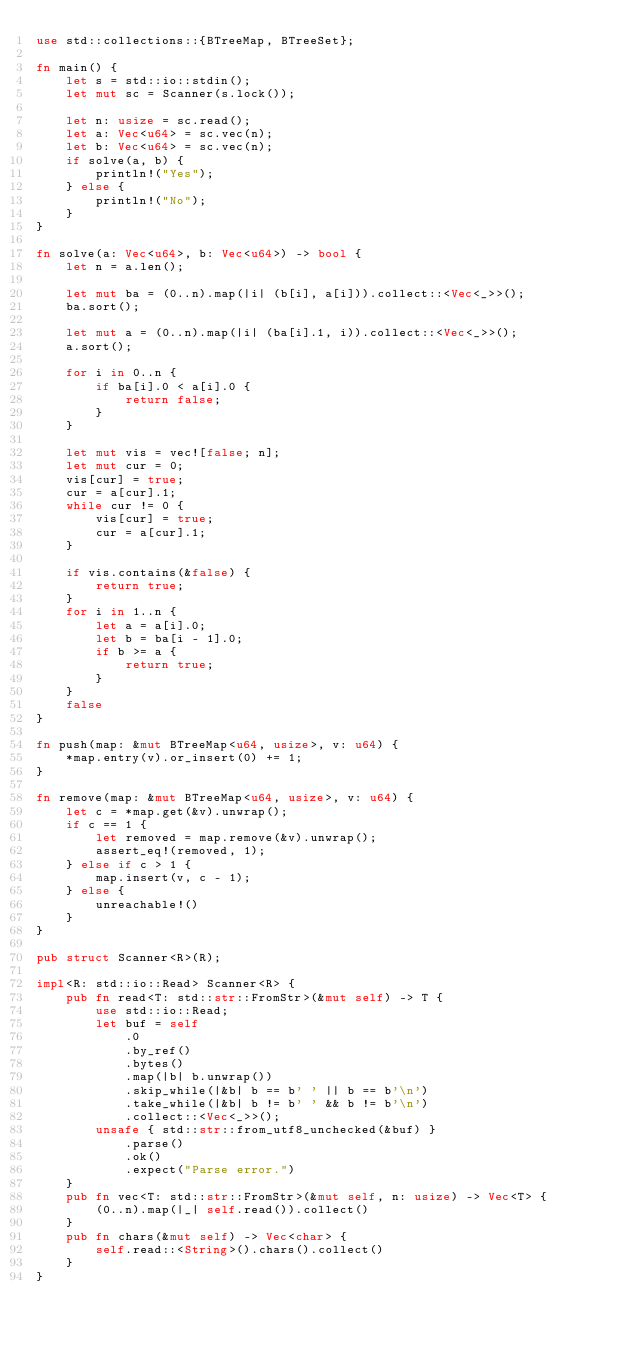<code> <loc_0><loc_0><loc_500><loc_500><_Rust_>use std::collections::{BTreeMap, BTreeSet};

fn main() {
    let s = std::io::stdin();
    let mut sc = Scanner(s.lock());

    let n: usize = sc.read();
    let a: Vec<u64> = sc.vec(n);
    let b: Vec<u64> = sc.vec(n);
    if solve(a, b) {
        println!("Yes");
    } else {
        println!("No");
    }
}

fn solve(a: Vec<u64>, b: Vec<u64>) -> bool {
    let n = a.len();

    let mut ba = (0..n).map(|i| (b[i], a[i])).collect::<Vec<_>>();
    ba.sort();

    let mut a = (0..n).map(|i| (ba[i].1, i)).collect::<Vec<_>>();
    a.sort();

    for i in 0..n {
        if ba[i].0 < a[i].0 {
            return false;
        }
    }

    let mut vis = vec![false; n];
    let mut cur = 0;
    vis[cur] = true;
    cur = a[cur].1;
    while cur != 0 {
        vis[cur] = true;
        cur = a[cur].1;
    }

    if vis.contains(&false) {
        return true;
    }
    for i in 1..n {
        let a = a[i].0;
        let b = ba[i - 1].0;
        if b >= a {
            return true;
        }
    }
    false
}

fn push(map: &mut BTreeMap<u64, usize>, v: u64) {
    *map.entry(v).or_insert(0) += 1;
}

fn remove(map: &mut BTreeMap<u64, usize>, v: u64) {
    let c = *map.get(&v).unwrap();
    if c == 1 {
        let removed = map.remove(&v).unwrap();
        assert_eq!(removed, 1);
    } else if c > 1 {
        map.insert(v, c - 1);
    } else {
        unreachable!()
    }
}

pub struct Scanner<R>(R);

impl<R: std::io::Read> Scanner<R> {
    pub fn read<T: std::str::FromStr>(&mut self) -> T {
        use std::io::Read;
        let buf = self
            .0
            .by_ref()
            .bytes()
            .map(|b| b.unwrap())
            .skip_while(|&b| b == b' ' || b == b'\n')
            .take_while(|&b| b != b' ' && b != b'\n')
            .collect::<Vec<_>>();
        unsafe { std::str::from_utf8_unchecked(&buf) }
            .parse()
            .ok()
            .expect("Parse error.")
    }
    pub fn vec<T: std::str::FromStr>(&mut self, n: usize) -> Vec<T> {
        (0..n).map(|_| self.read()).collect()
    }
    pub fn chars(&mut self) -> Vec<char> {
        self.read::<String>().chars().collect()
    }
}
</code> 